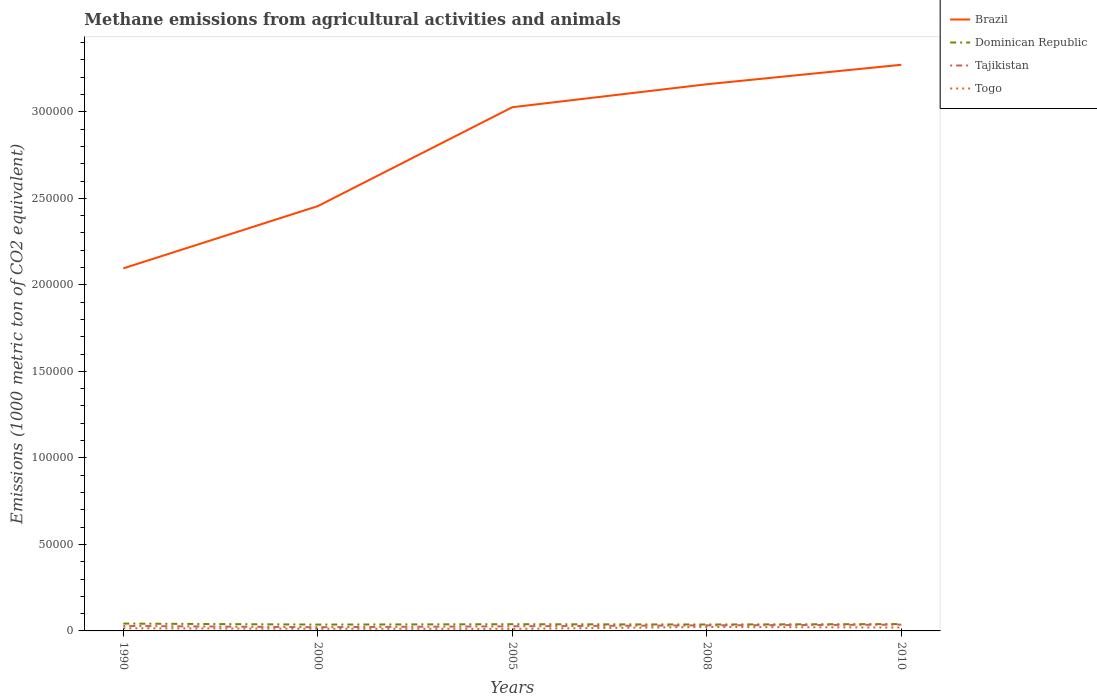Does the line corresponding to Dominican Republic intersect with the line corresponding to Togo?
Give a very brief answer. No. Across all years, what is the maximum amount of methane emitted in Togo?
Provide a short and direct response. 1193.3. In which year was the amount of methane emitted in Dominican Republic maximum?
Your answer should be compact. 2000. What is the total amount of methane emitted in Dominican Republic in the graph?
Provide a succinct answer. -41.7. What is the difference between the highest and the second highest amount of methane emitted in Brazil?
Provide a succinct answer. 1.18e+05. What is the difference between the highest and the lowest amount of methane emitted in Brazil?
Provide a short and direct response. 3. What is the difference between two consecutive major ticks on the Y-axis?
Provide a succinct answer. 5.00e+04. Does the graph contain any zero values?
Offer a terse response. No. Does the graph contain grids?
Provide a short and direct response. No. Where does the legend appear in the graph?
Make the answer very short. Top right. How many legend labels are there?
Your answer should be compact. 4. What is the title of the graph?
Your response must be concise. Methane emissions from agricultural activities and animals. What is the label or title of the X-axis?
Your response must be concise. Years. What is the label or title of the Y-axis?
Offer a terse response. Emissions (1000 metric ton of CO2 equivalent). What is the Emissions (1000 metric ton of CO2 equivalent) in Brazil in 1990?
Keep it short and to the point. 2.10e+05. What is the Emissions (1000 metric ton of CO2 equivalent) in Dominican Republic in 1990?
Provide a short and direct response. 4239.8. What is the Emissions (1000 metric ton of CO2 equivalent) of Tajikistan in 1990?
Your response must be concise. 2874.3. What is the Emissions (1000 metric ton of CO2 equivalent) in Togo in 1990?
Make the answer very short. 1531.1. What is the Emissions (1000 metric ton of CO2 equivalent) of Brazil in 2000?
Your answer should be very brief. 2.45e+05. What is the Emissions (1000 metric ton of CO2 equivalent) in Dominican Republic in 2000?
Your answer should be very brief. 3661.8. What is the Emissions (1000 metric ton of CO2 equivalent) in Tajikistan in 2000?
Offer a terse response. 2147.2. What is the Emissions (1000 metric ton of CO2 equivalent) of Togo in 2000?
Give a very brief answer. 1266.2. What is the Emissions (1000 metric ton of CO2 equivalent) in Brazil in 2005?
Your response must be concise. 3.03e+05. What is the Emissions (1000 metric ton of CO2 equivalent) in Dominican Republic in 2005?
Keep it short and to the point. 3878.6. What is the Emissions (1000 metric ton of CO2 equivalent) in Tajikistan in 2005?
Your response must be concise. 2672.7. What is the Emissions (1000 metric ton of CO2 equivalent) of Togo in 2005?
Offer a very short reply. 1193.3. What is the Emissions (1000 metric ton of CO2 equivalent) of Brazil in 2008?
Provide a short and direct response. 3.16e+05. What is the Emissions (1000 metric ton of CO2 equivalent) of Dominican Republic in 2008?
Give a very brief answer. 3703.5. What is the Emissions (1000 metric ton of CO2 equivalent) in Tajikistan in 2008?
Give a very brief answer. 3214.1. What is the Emissions (1000 metric ton of CO2 equivalent) in Togo in 2008?
Offer a very short reply. 2285.6. What is the Emissions (1000 metric ton of CO2 equivalent) of Brazil in 2010?
Keep it short and to the point. 3.27e+05. What is the Emissions (1000 metric ton of CO2 equivalent) of Dominican Republic in 2010?
Ensure brevity in your answer.  3952.7. What is the Emissions (1000 metric ton of CO2 equivalent) in Tajikistan in 2010?
Your answer should be very brief. 3620.1. What is the Emissions (1000 metric ton of CO2 equivalent) of Togo in 2010?
Make the answer very short. 1958.5. Across all years, what is the maximum Emissions (1000 metric ton of CO2 equivalent) of Brazil?
Provide a succinct answer. 3.27e+05. Across all years, what is the maximum Emissions (1000 metric ton of CO2 equivalent) in Dominican Republic?
Your answer should be compact. 4239.8. Across all years, what is the maximum Emissions (1000 metric ton of CO2 equivalent) in Tajikistan?
Provide a succinct answer. 3620.1. Across all years, what is the maximum Emissions (1000 metric ton of CO2 equivalent) of Togo?
Your answer should be compact. 2285.6. Across all years, what is the minimum Emissions (1000 metric ton of CO2 equivalent) in Brazil?
Give a very brief answer. 2.10e+05. Across all years, what is the minimum Emissions (1000 metric ton of CO2 equivalent) of Dominican Republic?
Keep it short and to the point. 3661.8. Across all years, what is the minimum Emissions (1000 metric ton of CO2 equivalent) in Tajikistan?
Your answer should be compact. 2147.2. Across all years, what is the minimum Emissions (1000 metric ton of CO2 equivalent) in Togo?
Keep it short and to the point. 1193.3. What is the total Emissions (1000 metric ton of CO2 equivalent) in Brazil in the graph?
Offer a very short reply. 1.40e+06. What is the total Emissions (1000 metric ton of CO2 equivalent) of Dominican Republic in the graph?
Provide a succinct answer. 1.94e+04. What is the total Emissions (1000 metric ton of CO2 equivalent) of Tajikistan in the graph?
Your answer should be very brief. 1.45e+04. What is the total Emissions (1000 metric ton of CO2 equivalent) of Togo in the graph?
Give a very brief answer. 8234.7. What is the difference between the Emissions (1000 metric ton of CO2 equivalent) in Brazil in 1990 and that in 2000?
Your answer should be very brief. -3.60e+04. What is the difference between the Emissions (1000 metric ton of CO2 equivalent) of Dominican Republic in 1990 and that in 2000?
Offer a very short reply. 578. What is the difference between the Emissions (1000 metric ton of CO2 equivalent) of Tajikistan in 1990 and that in 2000?
Provide a succinct answer. 727.1. What is the difference between the Emissions (1000 metric ton of CO2 equivalent) of Togo in 1990 and that in 2000?
Provide a short and direct response. 264.9. What is the difference between the Emissions (1000 metric ton of CO2 equivalent) of Brazil in 1990 and that in 2005?
Ensure brevity in your answer.  -9.31e+04. What is the difference between the Emissions (1000 metric ton of CO2 equivalent) in Dominican Republic in 1990 and that in 2005?
Your answer should be compact. 361.2. What is the difference between the Emissions (1000 metric ton of CO2 equivalent) in Tajikistan in 1990 and that in 2005?
Offer a very short reply. 201.6. What is the difference between the Emissions (1000 metric ton of CO2 equivalent) in Togo in 1990 and that in 2005?
Ensure brevity in your answer.  337.8. What is the difference between the Emissions (1000 metric ton of CO2 equivalent) of Brazil in 1990 and that in 2008?
Your answer should be compact. -1.06e+05. What is the difference between the Emissions (1000 metric ton of CO2 equivalent) in Dominican Republic in 1990 and that in 2008?
Offer a very short reply. 536.3. What is the difference between the Emissions (1000 metric ton of CO2 equivalent) in Tajikistan in 1990 and that in 2008?
Provide a succinct answer. -339.8. What is the difference between the Emissions (1000 metric ton of CO2 equivalent) of Togo in 1990 and that in 2008?
Give a very brief answer. -754.5. What is the difference between the Emissions (1000 metric ton of CO2 equivalent) in Brazil in 1990 and that in 2010?
Provide a short and direct response. -1.18e+05. What is the difference between the Emissions (1000 metric ton of CO2 equivalent) in Dominican Republic in 1990 and that in 2010?
Your response must be concise. 287.1. What is the difference between the Emissions (1000 metric ton of CO2 equivalent) of Tajikistan in 1990 and that in 2010?
Keep it short and to the point. -745.8. What is the difference between the Emissions (1000 metric ton of CO2 equivalent) in Togo in 1990 and that in 2010?
Offer a very short reply. -427.4. What is the difference between the Emissions (1000 metric ton of CO2 equivalent) in Brazil in 2000 and that in 2005?
Your answer should be very brief. -5.71e+04. What is the difference between the Emissions (1000 metric ton of CO2 equivalent) in Dominican Republic in 2000 and that in 2005?
Your answer should be compact. -216.8. What is the difference between the Emissions (1000 metric ton of CO2 equivalent) in Tajikistan in 2000 and that in 2005?
Offer a very short reply. -525.5. What is the difference between the Emissions (1000 metric ton of CO2 equivalent) in Togo in 2000 and that in 2005?
Ensure brevity in your answer.  72.9. What is the difference between the Emissions (1000 metric ton of CO2 equivalent) of Brazil in 2000 and that in 2008?
Provide a short and direct response. -7.04e+04. What is the difference between the Emissions (1000 metric ton of CO2 equivalent) of Dominican Republic in 2000 and that in 2008?
Ensure brevity in your answer.  -41.7. What is the difference between the Emissions (1000 metric ton of CO2 equivalent) of Tajikistan in 2000 and that in 2008?
Your response must be concise. -1066.9. What is the difference between the Emissions (1000 metric ton of CO2 equivalent) of Togo in 2000 and that in 2008?
Offer a terse response. -1019.4. What is the difference between the Emissions (1000 metric ton of CO2 equivalent) in Brazil in 2000 and that in 2010?
Provide a short and direct response. -8.17e+04. What is the difference between the Emissions (1000 metric ton of CO2 equivalent) of Dominican Republic in 2000 and that in 2010?
Ensure brevity in your answer.  -290.9. What is the difference between the Emissions (1000 metric ton of CO2 equivalent) in Tajikistan in 2000 and that in 2010?
Ensure brevity in your answer.  -1472.9. What is the difference between the Emissions (1000 metric ton of CO2 equivalent) in Togo in 2000 and that in 2010?
Offer a very short reply. -692.3. What is the difference between the Emissions (1000 metric ton of CO2 equivalent) of Brazil in 2005 and that in 2008?
Your response must be concise. -1.33e+04. What is the difference between the Emissions (1000 metric ton of CO2 equivalent) of Dominican Republic in 2005 and that in 2008?
Provide a succinct answer. 175.1. What is the difference between the Emissions (1000 metric ton of CO2 equivalent) of Tajikistan in 2005 and that in 2008?
Give a very brief answer. -541.4. What is the difference between the Emissions (1000 metric ton of CO2 equivalent) in Togo in 2005 and that in 2008?
Your response must be concise. -1092.3. What is the difference between the Emissions (1000 metric ton of CO2 equivalent) of Brazil in 2005 and that in 2010?
Your answer should be compact. -2.45e+04. What is the difference between the Emissions (1000 metric ton of CO2 equivalent) in Dominican Republic in 2005 and that in 2010?
Your answer should be very brief. -74.1. What is the difference between the Emissions (1000 metric ton of CO2 equivalent) in Tajikistan in 2005 and that in 2010?
Your answer should be very brief. -947.4. What is the difference between the Emissions (1000 metric ton of CO2 equivalent) of Togo in 2005 and that in 2010?
Offer a very short reply. -765.2. What is the difference between the Emissions (1000 metric ton of CO2 equivalent) in Brazil in 2008 and that in 2010?
Offer a terse response. -1.13e+04. What is the difference between the Emissions (1000 metric ton of CO2 equivalent) in Dominican Republic in 2008 and that in 2010?
Your answer should be compact. -249.2. What is the difference between the Emissions (1000 metric ton of CO2 equivalent) of Tajikistan in 2008 and that in 2010?
Provide a short and direct response. -406. What is the difference between the Emissions (1000 metric ton of CO2 equivalent) in Togo in 2008 and that in 2010?
Your answer should be very brief. 327.1. What is the difference between the Emissions (1000 metric ton of CO2 equivalent) in Brazil in 1990 and the Emissions (1000 metric ton of CO2 equivalent) in Dominican Republic in 2000?
Provide a short and direct response. 2.06e+05. What is the difference between the Emissions (1000 metric ton of CO2 equivalent) of Brazil in 1990 and the Emissions (1000 metric ton of CO2 equivalent) of Tajikistan in 2000?
Make the answer very short. 2.07e+05. What is the difference between the Emissions (1000 metric ton of CO2 equivalent) in Brazil in 1990 and the Emissions (1000 metric ton of CO2 equivalent) in Togo in 2000?
Give a very brief answer. 2.08e+05. What is the difference between the Emissions (1000 metric ton of CO2 equivalent) in Dominican Republic in 1990 and the Emissions (1000 metric ton of CO2 equivalent) in Tajikistan in 2000?
Offer a very short reply. 2092.6. What is the difference between the Emissions (1000 metric ton of CO2 equivalent) of Dominican Republic in 1990 and the Emissions (1000 metric ton of CO2 equivalent) of Togo in 2000?
Provide a succinct answer. 2973.6. What is the difference between the Emissions (1000 metric ton of CO2 equivalent) of Tajikistan in 1990 and the Emissions (1000 metric ton of CO2 equivalent) of Togo in 2000?
Offer a terse response. 1608.1. What is the difference between the Emissions (1000 metric ton of CO2 equivalent) in Brazil in 1990 and the Emissions (1000 metric ton of CO2 equivalent) in Dominican Republic in 2005?
Your answer should be very brief. 2.06e+05. What is the difference between the Emissions (1000 metric ton of CO2 equivalent) of Brazil in 1990 and the Emissions (1000 metric ton of CO2 equivalent) of Tajikistan in 2005?
Make the answer very short. 2.07e+05. What is the difference between the Emissions (1000 metric ton of CO2 equivalent) of Brazil in 1990 and the Emissions (1000 metric ton of CO2 equivalent) of Togo in 2005?
Make the answer very short. 2.08e+05. What is the difference between the Emissions (1000 metric ton of CO2 equivalent) of Dominican Republic in 1990 and the Emissions (1000 metric ton of CO2 equivalent) of Tajikistan in 2005?
Offer a terse response. 1567.1. What is the difference between the Emissions (1000 metric ton of CO2 equivalent) in Dominican Republic in 1990 and the Emissions (1000 metric ton of CO2 equivalent) in Togo in 2005?
Provide a succinct answer. 3046.5. What is the difference between the Emissions (1000 metric ton of CO2 equivalent) of Tajikistan in 1990 and the Emissions (1000 metric ton of CO2 equivalent) of Togo in 2005?
Make the answer very short. 1681. What is the difference between the Emissions (1000 metric ton of CO2 equivalent) in Brazil in 1990 and the Emissions (1000 metric ton of CO2 equivalent) in Dominican Republic in 2008?
Provide a short and direct response. 2.06e+05. What is the difference between the Emissions (1000 metric ton of CO2 equivalent) of Brazil in 1990 and the Emissions (1000 metric ton of CO2 equivalent) of Tajikistan in 2008?
Provide a short and direct response. 2.06e+05. What is the difference between the Emissions (1000 metric ton of CO2 equivalent) in Brazil in 1990 and the Emissions (1000 metric ton of CO2 equivalent) in Togo in 2008?
Keep it short and to the point. 2.07e+05. What is the difference between the Emissions (1000 metric ton of CO2 equivalent) in Dominican Republic in 1990 and the Emissions (1000 metric ton of CO2 equivalent) in Tajikistan in 2008?
Your response must be concise. 1025.7. What is the difference between the Emissions (1000 metric ton of CO2 equivalent) in Dominican Republic in 1990 and the Emissions (1000 metric ton of CO2 equivalent) in Togo in 2008?
Offer a terse response. 1954.2. What is the difference between the Emissions (1000 metric ton of CO2 equivalent) of Tajikistan in 1990 and the Emissions (1000 metric ton of CO2 equivalent) of Togo in 2008?
Offer a terse response. 588.7. What is the difference between the Emissions (1000 metric ton of CO2 equivalent) in Brazil in 1990 and the Emissions (1000 metric ton of CO2 equivalent) in Dominican Republic in 2010?
Offer a very short reply. 2.06e+05. What is the difference between the Emissions (1000 metric ton of CO2 equivalent) in Brazil in 1990 and the Emissions (1000 metric ton of CO2 equivalent) in Tajikistan in 2010?
Your answer should be very brief. 2.06e+05. What is the difference between the Emissions (1000 metric ton of CO2 equivalent) of Brazil in 1990 and the Emissions (1000 metric ton of CO2 equivalent) of Togo in 2010?
Your answer should be compact. 2.08e+05. What is the difference between the Emissions (1000 metric ton of CO2 equivalent) in Dominican Republic in 1990 and the Emissions (1000 metric ton of CO2 equivalent) in Tajikistan in 2010?
Your response must be concise. 619.7. What is the difference between the Emissions (1000 metric ton of CO2 equivalent) of Dominican Republic in 1990 and the Emissions (1000 metric ton of CO2 equivalent) of Togo in 2010?
Give a very brief answer. 2281.3. What is the difference between the Emissions (1000 metric ton of CO2 equivalent) of Tajikistan in 1990 and the Emissions (1000 metric ton of CO2 equivalent) of Togo in 2010?
Provide a succinct answer. 915.8. What is the difference between the Emissions (1000 metric ton of CO2 equivalent) of Brazil in 2000 and the Emissions (1000 metric ton of CO2 equivalent) of Dominican Republic in 2005?
Give a very brief answer. 2.42e+05. What is the difference between the Emissions (1000 metric ton of CO2 equivalent) in Brazil in 2000 and the Emissions (1000 metric ton of CO2 equivalent) in Tajikistan in 2005?
Offer a terse response. 2.43e+05. What is the difference between the Emissions (1000 metric ton of CO2 equivalent) in Brazil in 2000 and the Emissions (1000 metric ton of CO2 equivalent) in Togo in 2005?
Provide a short and direct response. 2.44e+05. What is the difference between the Emissions (1000 metric ton of CO2 equivalent) in Dominican Republic in 2000 and the Emissions (1000 metric ton of CO2 equivalent) in Tajikistan in 2005?
Provide a short and direct response. 989.1. What is the difference between the Emissions (1000 metric ton of CO2 equivalent) of Dominican Republic in 2000 and the Emissions (1000 metric ton of CO2 equivalent) of Togo in 2005?
Ensure brevity in your answer.  2468.5. What is the difference between the Emissions (1000 metric ton of CO2 equivalent) of Tajikistan in 2000 and the Emissions (1000 metric ton of CO2 equivalent) of Togo in 2005?
Your answer should be very brief. 953.9. What is the difference between the Emissions (1000 metric ton of CO2 equivalent) of Brazil in 2000 and the Emissions (1000 metric ton of CO2 equivalent) of Dominican Republic in 2008?
Ensure brevity in your answer.  2.42e+05. What is the difference between the Emissions (1000 metric ton of CO2 equivalent) in Brazil in 2000 and the Emissions (1000 metric ton of CO2 equivalent) in Tajikistan in 2008?
Provide a succinct answer. 2.42e+05. What is the difference between the Emissions (1000 metric ton of CO2 equivalent) of Brazil in 2000 and the Emissions (1000 metric ton of CO2 equivalent) of Togo in 2008?
Make the answer very short. 2.43e+05. What is the difference between the Emissions (1000 metric ton of CO2 equivalent) in Dominican Republic in 2000 and the Emissions (1000 metric ton of CO2 equivalent) in Tajikistan in 2008?
Offer a terse response. 447.7. What is the difference between the Emissions (1000 metric ton of CO2 equivalent) in Dominican Republic in 2000 and the Emissions (1000 metric ton of CO2 equivalent) in Togo in 2008?
Your answer should be very brief. 1376.2. What is the difference between the Emissions (1000 metric ton of CO2 equivalent) in Tajikistan in 2000 and the Emissions (1000 metric ton of CO2 equivalent) in Togo in 2008?
Give a very brief answer. -138.4. What is the difference between the Emissions (1000 metric ton of CO2 equivalent) in Brazil in 2000 and the Emissions (1000 metric ton of CO2 equivalent) in Dominican Republic in 2010?
Give a very brief answer. 2.42e+05. What is the difference between the Emissions (1000 metric ton of CO2 equivalent) of Brazil in 2000 and the Emissions (1000 metric ton of CO2 equivalent) of Tajikistan in 2010?
Keep it short and to the point. 2.42e+05. What is the difference between the Emissions (1000 metric ton of CO2 equivalent) of Brazil in 2000 and the Emissions (1000 metric ton of CO2 equivalent) of Togo in 2010?
Ensure brevity in your answer.  2.44e+05. What is the difference between the Emissions (1000 metric ton of CO2 equivalent) in Dominican Republic in 2000 and the Emissions (1000 metric ton of CO2 equivalent) in Tajikistan in 2010?
Your answer should be compact. 41.7. What is the difference between the Emissions (1000 metric ton of CO2 equivalent) in Dominican Republic in 2000 and the Emissions (1000 metric ton of CO2 equivalent) in Togo in 2010?
Make the answer very short. 1703.3. What is the difference between the Emissions (1000 metric ton of CO2 equivalent) in Tajikistan in 2000 and the Emissions (1000 metric ton of CO2 equivalent) in Togo in 2010?
Provide a succinct answer. 188.7. What is the difference between the Emissions (1000 metric ton of CO2 equivalent) of Brazil in 2005 and the Emissions (1000 metric ton of CO2 equivalent) of Dominican Republic in 2008?
Provide a succinct answer. 2.99e+05. What is the difference between the Emissions (1000 metric ton of CO2 equivalent) of Brazil in 2005 and the Emissions (1000 metric ton of CO2 equivalent) of Tajikistan in 2008?
Your answer should be very brief. 2.99e+05. What is the difference between the Emissions (1000 metric ton of CO2 equivalent) of Brazil in 2005 and the Emissions (1000 metric ton of CO2 equivalent) of Togo in 2008?
Make the answer very short. 3.00e+05. What is the difference between the Emissions (1000 metric ton of CO2 equivalent) in Dominican Republic in 2005 and the Emissions (1000 metric ton of CO2 equivalent) in Tajikistan in 2008?
Offer a terse response. 664.5. What is the difference between the Emissions (1000 metric ton of CO2 equivalent) in Dominican Republic in 2005 and the Emissions (1000 metric ton of CO2 equivalent) in Togo in 2008?
Make the answer very short. 1593. What is the difference between the Emissions (1000 metric ton of CO2 equivalent) in Tajikistan in 2005 and the Emissions (1000 metric ton of CO2 equivalent) in Togo in 2008?
Give a very brief answer. 387.1. What is the difference between the Emissions (1000 metric ton of CO2 equivalent) of Brazil in 2005 and the Emissions (1000 metric ton of CO2 equivalent) of Dominican Republic in 2010?
Your response must be concise. 2.99e+05. What is the difference between the Emissions (1000 metric ton of CO2 equivalent) of Brazil in 2005 and the Emissions (1000 metric ton of CO2 equivalent) of Tajikistan in 2010?
Keep it short and to the point. 2.99e+05. What is the difference between the Emissions (1000 metric ton of CO2 equivalent) in Brazil in 2005 and the Emissions (1000 metric ton of CO2 equivalent) in Togo in 2010?
Provide a succinct answer. 3.01e+05. What is the difference between the Emissions (1000 metric ton of CO2 equivalent) of Dominican Republic in 2005 and the Emissions (1000 metric ton of CO2 equivalent) of Tajikistan in 2010?
Your answer should be compact. 258.5. What is the difference between the Emissions (1000 metric ton of CO2 equivalent) of Dominican Republic in 2005 and the Emissions (1000 metric ton of CO2 equivalent) of Togo in 2010?
Your answer should be very brief. 1920.1. What is the difference between the Emissions (1000 metric ton of CO2 equivalent) of Tajikistan in 2005 and the Emissions (1000 metric ton of CO2 equivalent) of Togo in 2010?
Your response must be concise. 714.2. What is the difference between the Emissions (1000 metric ton of CO2 equivalent) of Brazil in 2008 and the Emissions (1000 metric ton of CO2 equivalent) of Dominican Republic in 2010?
Your response must be concise. 3.12e+05. What is the difference between the Emissions (1000 metric ton of CO2 equivalent) of Brazil in 2008 and the Emissions (1000 metric ton of CO2 equivalent) of Tajikistan in 2010?
Your answer should be compact. 3.12e+05. What is the difference between the Emissions (1000 metric ton of CO2 equivalent) in Brazil in 2008 and the Emissions (1000 metric ton of CO2 equivalent) in Togo in 2010?
Provide a short and direct response. 3.14e+05. What is the difference between the Emissions (1000 metric ton of CO2 equivalent) in Dominican Republic in 2008 and the Emissions (1000 metric ton of CO2 equivalent) in Tajikistan in 2010?
Make the answer very short. 83.4. What is the difference between the Emissions (1000 metric ton of CO2 equivalent) of Dominican Republic in 2008 and the Emissions (1000 metric ton of CO2 equivalent) of Togo in 2010?
Give a very brief answer. 1745. What is the difference between the Emissions (1000 metric ton of CO2 equivalent) in Tajikistan in 2008 and the Emissions (1000 metric ton of CO2 equivalent) in Togo in 2010?
Keep it short and to the point. 1255.6. What is the average Emissions (1000 metric ton of CO2 equivalent) of Brazil per year?
Offer a very short reply. 2.80e+05. What is the average Emissions (1000 metric ton of CO2 equivalent) in Dominican Republic per year?
Your answer should be compact. 3887.28. What is the average Emissions (1000 metric ton of CO2 equivalent) in Tajikistan per year?
Provide a succinct answer. 2905.68. What is the average Emissions (1000 metric ton of CO2 equivalent) of Togo per year?
Provide a short and direct response. 1646.94. In the year 1990, what is the difference between the Emissions (1000 metric ton of CO2 equivalent) in Brazil and Emissions (1000 metric ton of CO2 equivalent) in Dominican Republic?
Keep it short and to the point. 2.05e+05. In the year 1990, what is the difference between the Emissions (1000 metric ton of CO2 equivalent) in Brazil and Emissions (1000 metric ton of CO2 equivalent) in Tajikistan?
Provide a short and direct response. 2.07e+05. In the year 1990, what is the difference between the Emissions (1000 metric ton of CO2 equivalent) of Brazil and Emissions (1000 metric ton of CO2 equivalent) of Togo?
Offer a very short reply. 2.08e+05. In the year 1990, what is the difference between the Emissions (1000 metric ton of CO2 equivalent) in Dominican Republic and Emissions (1000 metric ton of CO2 equivalent) in Tajikistan?
Provide a succinct answer. 1365.5. In the year 1990, what is the difference between the Emissions (1000 metric ton of CO2 equivalent) of Dominican Republic and Emissions (1000 metric ton of CO2 equivalent) of Togo?
Your answer should be very brief. 2708.7. In the year 1990, what is the difference between the Emissions (1000 metric ton of CO2 equivalent) in Tajikistan and Emissions (1000 metric ton of CO2 equivalent) in Togo?
Your answer should be compact. 1343.2. In the year 2000, what is the difference between the Emissions (1000 metric ton of CO2 equivalent) in Brazil and Emissions (1000 metric ton of CO2 equivalent) in Dominican Republic?
Your answer should be very brief. 2.42e+05. In the year 2000, what is the difference between the Emissions (1000 metric ton of CO2 equivalent) of Brazil and Emissions (1000 metric ton of CO2 equivalent) of Tajikistan?
Give a very brief answer. 2.43e+05. In the year 2000, what is the difference between the Emissions (1000 metric ton of CO2 equivalent) of Brazil and Emissions (1000 metric ton of CO2 equivalent) of Togo?
Give a very brief answer. 2.44e+05. In the year 2000, what is the difference between the Emissions (1000 metric ton of CO2 equivalent) of Dominican Republic and Emissions (1000 metric ton of CO2 equivalent) of Tajikistan?
Provide a short and direct response. 1514.6. In the year 2000, what is the difference between the Emissions (1000 metric ton of CO2 equivalent) in Dominican Republic and Emissions (1000 metric ton of CO2 equivalent) in Togo?
Your answer should be very brief. 2395.6. In the year 2000, what is the difference between the Emissions (1000 metric ton of CO2 equivalent) of Tajikistan and Emissions (1000 metric ton of CO2 equivalent) of Togo?
Ensure brevity in your answer.  881. In the year 2005, what is the difference between the Emissions (1000 metric ton of CO2 equivalent) of Brazil and Emissions (1000 metric ton of CO2 equivalent) of Dominican Republic?
Your answer should be compact. 2.99e+05. In the year 2005, what is the difference between the Emissions (1000 metric ton of CO2 equivalent) in Brazil and Emissions (1000 metric ton of CO2 equivalent) in Tajikistan?
Offer a terse response. 3.00e+05. In the year 2005, what is the difference between the Emissions (1000 metric ton of CO2 equivalent) in Brazil and Emissions (1000 metric ton of CO2 equivalent) in Togo?
Ensure brevity in your answer.  3.01e+05. In the year 2005, what is the difference between the Emissions (1000 metric ton of CO2 equivalent) of Dominican Republic and Emissions (1000 metric ton of CO2 equivalent) of Tajikistan?
Ensure brevity in your answer.  1205.9. In the year 2005, what is the difference between the Emissions (1000 metric ton of CO2 equivalent) of Dominican Republic and Emissions (1000 metric ton of CO2 equivalent) of Togo?
Provide a succinct answer. 2685.3. In the year 2005, what is the difference between the Emissions (1000 metric ton of CO2 equivalent) of Tajikistan and Emissions (1000 metric ton of CO2 equivalent) of Togo?
Keep it short and to the point. 1479.4. In the year 2008, what is the difference between the Emissions (1000 metric ton of CO2 equivalent) in Brazil and Emissions (1000 metric ton of CO2 equivalent) in Dominican Republic?
Provide a succinct answer. 3.12e+05. In the year 2008, what is the difference between the Emissions (1000 metric ton of CO2 equivalent) of Brazil and Emissions (1000 metric ton of CO2 equivalent) of Tajikistan?
Give a very brief answer. 3.13e+05. In the year 2008, what is the difference between the Emissions (1000 metric ton of CO2 equivalent) in Brazil and Emissions (1000 metric ton of CO2 equivalent) in Togo?
Ensure brevity in your answer.  3.14e+05. In the year 2008, what is the difference between the Emissions (1000 metric ton of CO2 equivalent) in Dominican Republic and Emissions (1000 metric ton of CO2 equivalent) in Tajikistan?
Offer a terse response. 489.4. In the year 2008, what is the difference between the Emissions (1000 metric ton of CO2 equivalent) in Dominican Republic and Emissions (1000 metric ton of CO2 equivalent) in Togo?
Provide a short and direct response. 1417.9. In the year 2008, what is the difference between the Emissions (1000 metric ton of CO2 equivalent) in Tajikistan and Emissions (1000 metric ton of CO2 equivalent) in Togo?
Provide a succinct answer. 928.5. In the year 2010, what is the difference between the Emissions (1000 metric ton of CO2 equivalent) of Brazil and Emissions (1000 metric ton of CO2 equivalent) of Dominican Republic?
Your answer should be very brief. 3.23e+05. In the year 2010, what is the difference between the Emissions (1000 metric ton of CO2 equivalent) in Brazil and Emissions (1000 metric ton of CO2 equivalent) in Tajikistan?
Your answer should be very brief. 3.24e+05. In the year 2010, what is the difference between the Emissions (1000 metric ton of CO2 equivalent) in Brazil and Emissions (1000 metric ton of CO2 equivalent) in Togo?
Make the answer very short. 3.25e+05. In the year 2010, what is the difference between the Emissions (1000 metric ton of CO2 equivalent) in Dominican Republic and Emissions (1000 metric ton of CO2 equivalent) in Tajikistan?
Your response must be concise. 332.6. In the year 2010, what is the difference between the Emissions (1000 metric ton of CO2 equivalent) in Dominican Republic and Emissions (1000 metric ton of CO2 equivalent) in Togo?
Ensure brevity in your answer.  1994.2. In the year 2010, what is the difference between the Emissions (1000 metric ton of CO2 equivalent) in Tajikistan and Emissions (1000 metric ton of CO2 equivalent) in Togo?
Offer a very short reply. 1661.6. What is the ratio of the Emissions (1000 metric ton of CO2 equivalent) in Brazil in 1990 to that in 2000?
Make the answer very short. 0.85. What is the ratio of the Emissions (1000 metric ton of CO2 equivalent) of Dominican Republic in 1990 to that in 2000?
Offer a very short reply. 1.16. What is the ratio of the Emissions (1000 metric ton of CO2 equivalent) in Tajikistan in 1990 to that in 2000?
Provide a succinct answer. 1.34. What is the ratio of the Emissions (1000 metric ton of CO2 equivalent) of Togo in 1990 to that in 2000?
Offer a very short reply. 1.21. What is the ratio of the Emissions (1000 metric ton of CO2 equivalent) in Brazil in 1990 to that in 2005?
Make the answer very short. 0.69. What is the ratio of the Emissions (1000 metric ton of CO2 equivalent) in Dominican Republic in 1990 to that in 2005?
Your answer should be compact. 1.09. What is the ratio of the Emissions (1000 metric ton of CO2 equivalent) of Tajikistan in 1990 to that in 2005?
Provide a short and direct response. 1.08. What is the ratio of the Emissions (1000 metric ton of CO2 equivalent) in Togo in 1990 to that in 2005?
Make the answer very short. 1.28. What is the ratio of the Emissions (1000 metric ton of CO2 equivalent) in Brazil in 1990 to that in 2008?
Your response must be concise. 0.66. What is the ratio of the Emissions (1000 metric ton of CO2 equivalent) of Dominican Republic in 1990 to that in 2008?
Your answer should be compact. 1.14. What is the ratio of the Emissions (1000 metric ton of CO2 equivalent) in Tajikistan in 1990 to that in 2008?
Offer a terse response. 0.89. What is the ratio of the Emissions (1000 metric ton of CO2 equivalent) in Togo in 1990 to that in 2008?
Your answer should be compact. 0.67. What is the ratio of the Emissions (1000 metric ton of CO2 equivalent) in Brazil in 1990 to that in 2010?
Offer a terse response. 0.64. What is the ratio of the Emissions (1000 metric ton of CO2 equivalent) of Dominican Republic in 1990 to that in 2010?
Make the answer very short. 1.07. What is the ratio of the Emissions (1000 metric ton of CO2 equivalent) in Tajikistan in 1990 to that in 2010?
Ensure brevity in your answer.  0.79. What is the ratio of the Emissions (1000 metric ton of CO2 equivalent) of Togo in 1990 to that in 2010?
Offer a terse response. 0.78. What is the ratio of the Emissions (1000 metric ton of CO2 equivalent) of Brazil in 2000 to that in 2005?
Make the answer very short. 0.81. What is the ratio of the Emissions (1000 metric ton of CO2 equivalent) in Dominican Republic in 2000 to that in 2005?
Give a very brief answer. 0.94. What is the ratio of the Emissions (1000 metric ton of CO2 equivalent) of Tajikistan in 2000 to that in 2005?
Offer a terse response. 0.8. What is the ratio of the Emissions (1000 metric ton of CO2 equivalent) in Togo in 2000 to that in 2005?
Make the answer very short. 1.06. What is the ratio of the Emissions (1000 metric ton of CO2 equivalent) of Brazil in 2000 to that in 2008?
Your answer should be compact. 0.78. What is the ratio of the Emissions (1000 metric ton of CO2 equivalent) in Dominican Republic in 2000 to that in 2008?
Provide a short and direct response. 0.99. What is the ratio of the Emissions (1000 metric ton of CO2 equivalent) in Tajikistan in 2000 to that in 2008?
Provide a short and direct response. 0.67. What is the ratio of the Emissions (1000 metric ton of CO2 equivalent) of Togo in 2000 to that in 2008?
Your answer should be very brief. 0.55. What is the ratio of the Emissions (1000 metric ton of CO2 equivalent) in Brazil in 2000 to that in 2010?
Offer a terse response. 0.75. What is the ratio of the Emissions (1000 metric ton of CO2 equivalent) of Dominican Republic in 2000 to that in 2010?
Give a very brief answer. 0.93. What is the ratio of the Emissions (1000 metric ton of CO2 equivalent) of Tajikistan in 2000 to that in 2010?
Give a very brief answer. 0.59. What is the ratio of the Emissions (1000 metric ton of CO2 equivalent) in Togo in 2000 to that in 2010?
Offer a terse response. 0.65. What is the ratio of the Emissions (1000 metric ton of CO2 equivalent) in Brazil in 2005 to that in 2008?
Keep it short and to the point. 0.96. What is the ratio of the Emissions (1000 metric ton of CO2 equivalent) of Dominican Republic in 2005 to that in 2008?
Your answer should be very brief. 1.05. What is the ratio of the Emissions (1000 metric ton of CO2 equivalent) of Tajikistan in 2005 to that in 2008?
Ensure brevity in your answer.  0.83. What is the ratio of the Emissions (1000 metric ton of CO2 equivalent) in Togo in 2005 to that in 2008?
Provide a succinct answer. 0.52. What is the ratio of the Emissions (1000 metric ton of CO2 equivalent) of Brazil in 2005 to that in 2010?
Your answer should be compact. 0.93. What is the ratio of the Emissions (1000 metric ton of CO2 equivalent) of Dominican Republic in 2005 to that in 2010?
Your response must be concise. 0.98. What is the ratio of the Emissions (1000 metric ton of CO2 equivalent) in Tajikistan in 2005 to that in 2010?
Your answer should be compact. 0.74. What is the ratio of the Emissions (1000 metric ton of CO2 equivalent) in Togo in 2005 to that in 2010?
Your response must be concise. 0.61. What is the ratio of the Emissions (1000 metric ton of CO2 equivalent) in Brazil in 2008 to that in 2010?
Make the answer very short. 0.97. What is the ratio of the Emissions (1000 metric ton of CO2 equivalent) of Dominican Republic in 2008 to that in 2010?
Make the answer very short. 0.94. What is the ratio of the Emissions (1000 metric ton of CO2 equivalent) in Tajikistan in 2008 to that in 2010?
Keep it short and to the point. 0.89. What is the ratio of the Emissions (1000 metric ton of CO2 equivalent) in Togo in 2008 to that in 2010?
Provide a succinct answer. 1.17. What is the difference between the highest and the second highest Emissions (1000 metric ton of CO2 equivalent) in Brazil?
Offer a terse response. 1.13e+04. What is the difference between the highest and the second highest Emissions (1000 metric ton of CO2 equivalent) in Dominican Republic?
Ensure brevity in your answer.  287.1. What is the difference between the highest and the second highest Emissions (1000 metric ton of CO2 equivalent) of Tajikistan?
Provide a succinct answer. 406. What is the difference between the highest and the second highest Emissions (1000 metric ton of CO2 equivalent) of Togo?
Provide a short and direct response. 327.1. What is the difference between the highest and the lowest Emissions (1000 metric ton of CO2 equivalent) in Brazil?
Give a very brief answer. 1.18e+05. What is the difference between the highest and the lowest Emissions (1000 metric ton of CO2 equivalent) in Dominican Republic?
Your answer should be compact. 578. What is the difference between the highest and the lowest Emissions (1000 metric ton of CO2 equivalent) of Tajikistan?
Your response must be concise. 1472.9. What is the difference between the highest and the lowest Emissions (1000 metric ton of CO2 equivalent) of Togo?
Your answer should be very brief. 1092.3. 